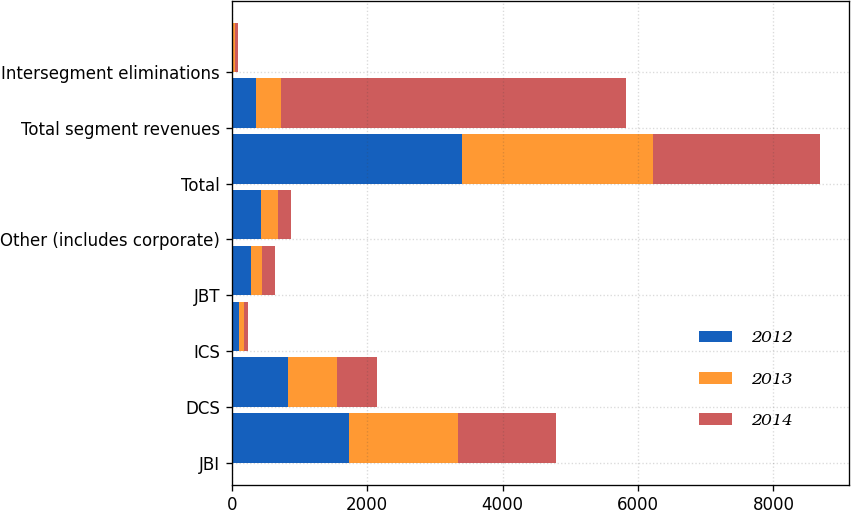<chart> <loc_0><loc_0><loc_500><loc_500><stacked_bar_chart><ecel><fcel>JBI<fcel>DCS<fcel>ICS<fcel>JBT<fcel>Other (includes corporate)<fcel>Total<fcel>Total segment revenues<fcel>Intersegment eliminations<nl><fcel>2012<fcel>1733<fcel>832<fcel>106<fcel>289<fcel>437<fcel>3397<fcel>363<fcel>20<nl><fcel>2013<fcel>1611<fcel>721<fcel>78<fcel>164<fcel>245<fcel>2819<fcel>363<fcel>30<nl><fcel>2014<fcel>1443<fcel>586<fcel>55<fcel>185<fcel>196<fcel>2465<fcel>5091<fcel>36<nl></chart> 